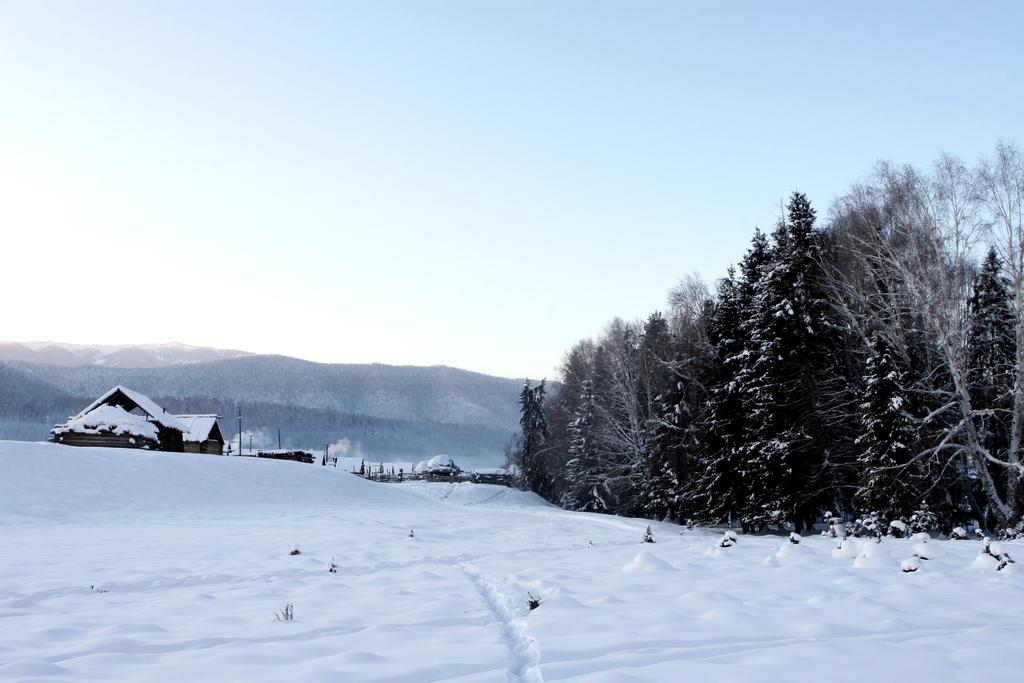What type of vegetation is present in the image? There are trees in the image. What is covering the ground in the image? There is snow in the image. What type of structure can be seen in the image? There is a house in the image. What are the tall, thin objects in the image? There are poles in the image. What can be seen in the distance in the image? There are mountains visible in the background of the image. What is visible above the mountains in the image? The sky is visible in the background of the image. What type of blade is being used to perform arithmetic calculations in the image? There is no blade or arithmetic calculations present in the image. Can you tell me how many knees are visible in the image? There are no knees visible in the image. 